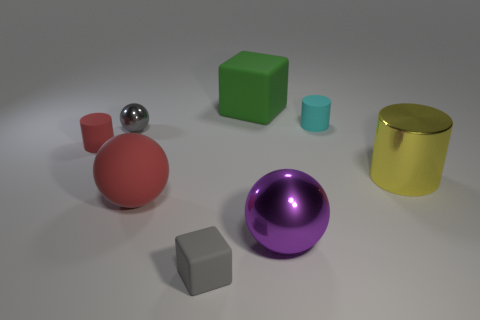Is there a tiny gray metal thing of the same shape as the green object? Upon reviewing the image, there is no tiny gray metal object that matches the shape of the green cube present. All objects are distinct both in color and material. 